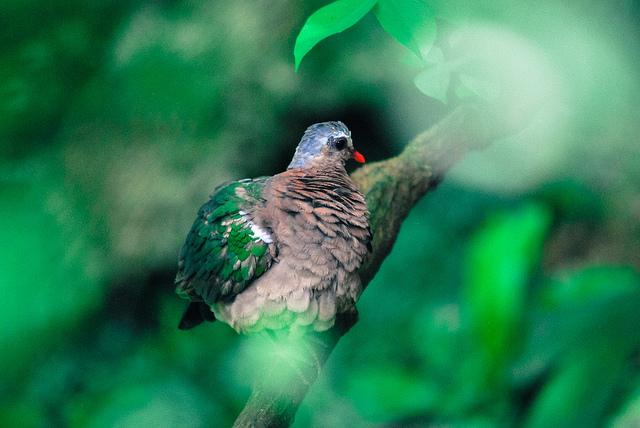What kind of bird is this?
Answer briefly. Finch. Is the bird pretty?
Be succinct. Yes. Is this a male or female bird?
Concise answer only. Male. What is the bird doing in the tree?
Be succinct. Resting. 